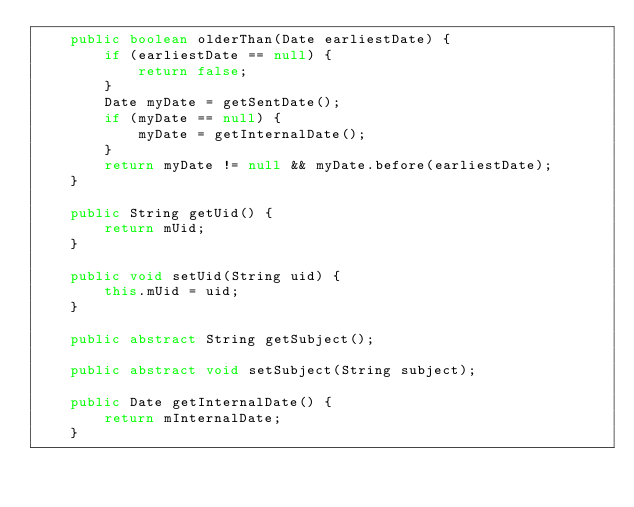Convert code to text. <code><loc_0><loc_0><loc_500><loc_500><_Java_>    public boolean olderThan(Date earliestDate) {
        if (earliestDate == null) {
            return false;
        }
        Date myDate = getSentDate();
        if (myDate == null) {
            myDate = getInternalDate();
        }
        return myDate != null && myDate.before(earliestDate);
    }

    public String getUid() {
        return mUid;
    }

    public void setUid(String uid) {
        this.mUid = uid;
    }

    public abstract String getSubject();

    public abstract void setSubject(String subject);

    public Date getInternalDate() {
        return mInternalDate;
    }
</code> 